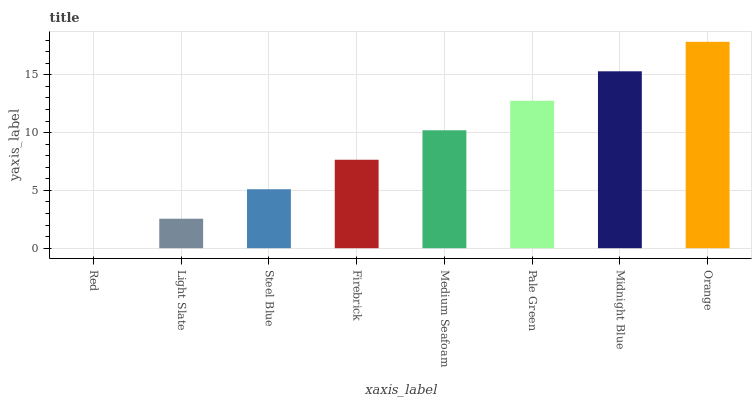Is Red the minimum?
Answer yes or no. Yes. Is Orange the maximum?
Answer yes or no. Yes. Is Light Slate the minimum?
Answer yes or no. No. Is Light Slate the maximum?
Answer yes or no. No. Is Light Slate greater than Red?
Answer yes or no. Yes. Is Red less than Light Slate?
Answer yes or no. Yes. Is Red greater than Light Slate?
Answer yes or no. No. Is Light Slate less than Red?
Answer yes or no. No. Is Medium Seafoam the high median?
Answer yes or no. Yes. Is Firebrick the low median?
Answer yes or no. Yes. Is Firebrick the high median?
Answer yes or no. No. Is Pale Green the low median?
Answer yes or no. No. 